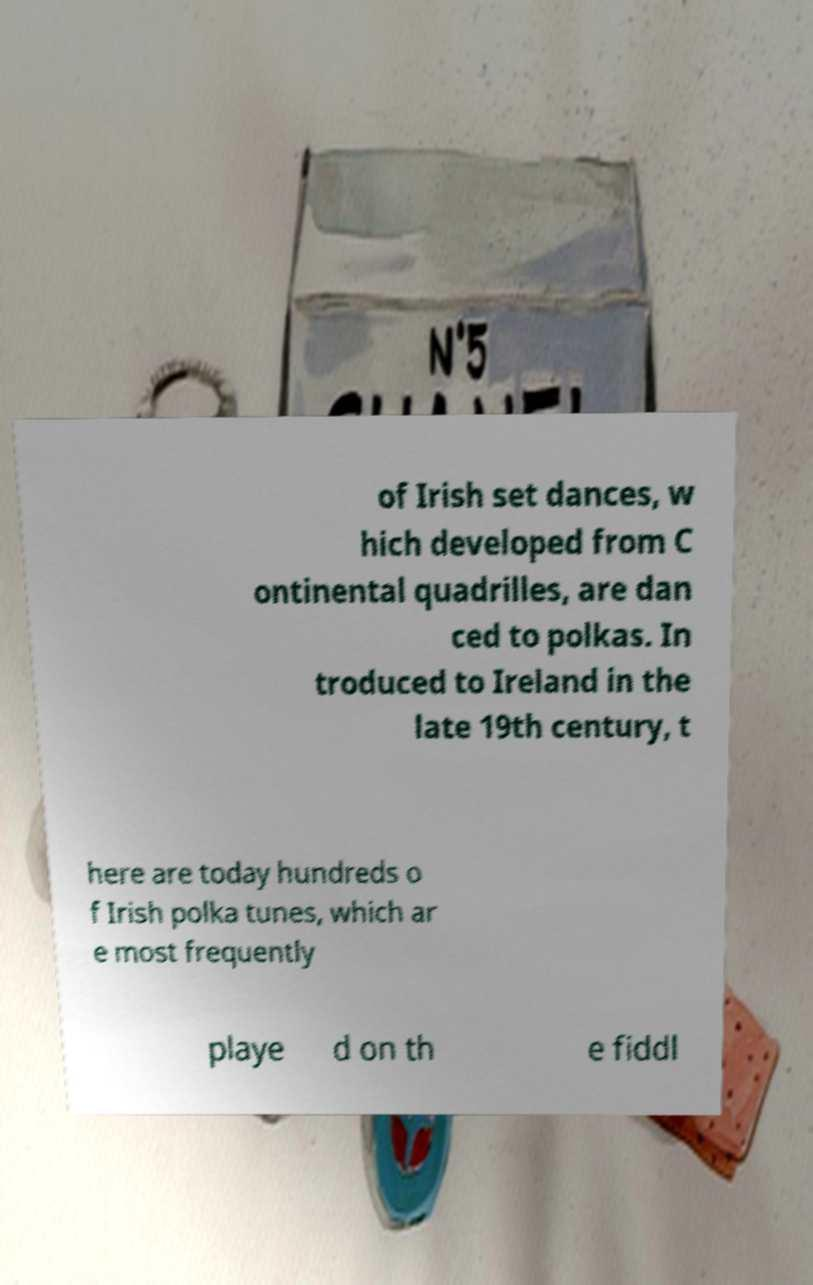Please read and relay the text visible in this image. What does it say? of Irish set dances, w hich developed from C ontinental quadrilles, are dan ced to polkas. In troduced to Ireland in the late 19th century, t here are today hundreds o f Irish polka tunes, which ar e most frequently playe d on th e fiddl 